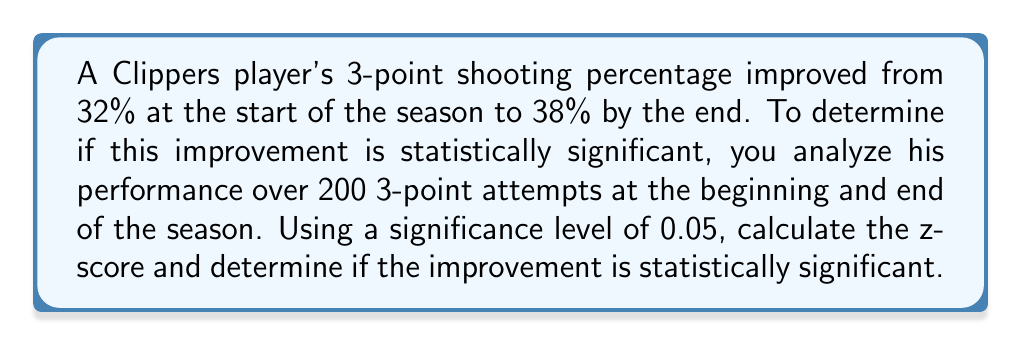Can you solve this math problem? Let's approach this step-by-step:

1) First, we need to define our null and alternative hypotheses:
   $H_0: p_1 = p_2$ (no significant difference)
   $H_a: p_1 < p_2$ (significant improvement)

   Where $p_1$ is the initial proportion (32%) and $p_2$ is the final proportion (38%).

2) We'll use a z-test for two population proportions. The formula is:

   $$z = \frac{(\hat{p_2} - \hat{p_1}) - (p_2 - p_1)}{\sqrt{\frac{p(1-p)}{n_1} + \frac{p(1-p)}{n_2}}}$$

   Where $p = \frac{n_1p_1 + n_2p_2}{n_1 + n_2}$ (pooled proportion)

3) Calculate the pooled proportion:
   $$p = \frac{200(0.32) + 200(0.38)}{200 + 200} = 0.35$$

4) Now, let's substitute into the z-score formula:

   $$z = \frac{(0.38 - 0.32) - 0}{\sqrt{\frac{0.35(1-0.35)}{200} + \frac{0.35(1-0.35)}{200}}}$$

5) Simplify:
   $$z = \frac{0.06}{\sqrt{\frac{0.2275}{200} + \frac{0.2275}{200}}} = \frac{0.06}{\sqrt{0.002275}} \approx 1.258$$

6) For a one-tailed test at 0.05 significance level, the critical z-value is 1.645.

7) Since our calculated z-score (1.258) is less than the critical value (1.645), we fail to reject the null hypothesis.
Answer: Not statistically significant (z = 1.258 < 1.645) 